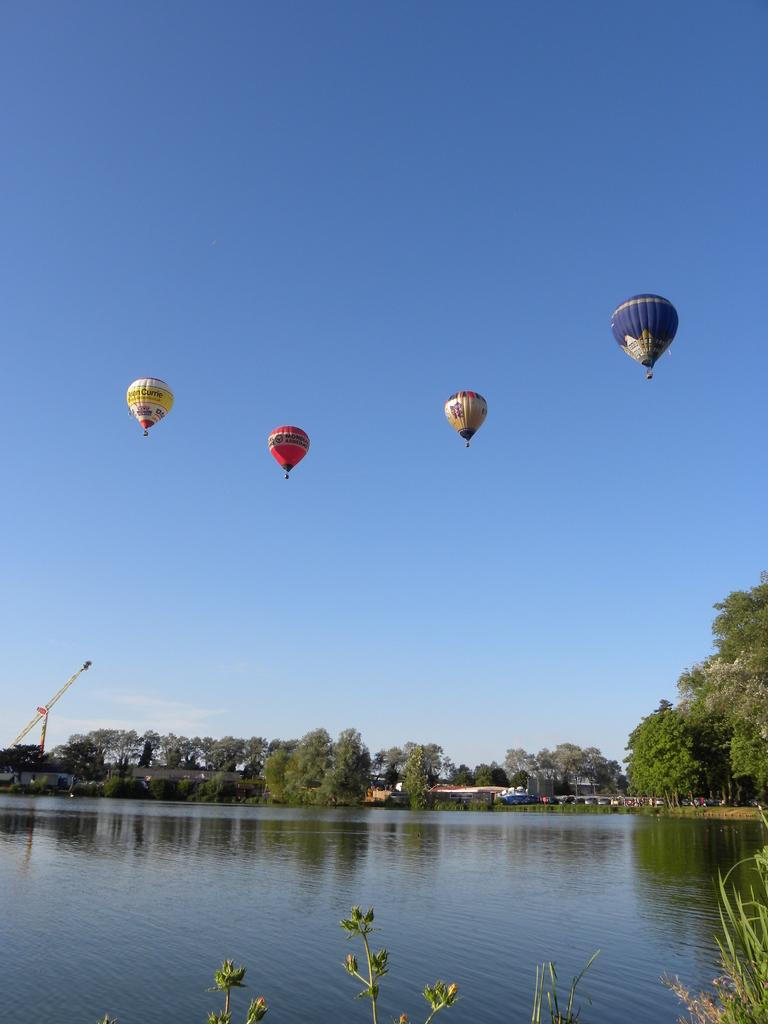What is in the air in the image? There are hot air balloons in the air in the image. What type of vegetation can be seen in the image? There are trees visible in the image. What natural element is visible in the image? There is water visible in the image. What type of structures can be seen in the image? There are houses in the image. What construction equipment is present in the image? There is a crane in the image. What is the color of the sky in the image? The sky is blue in the image. Where is the board used for playing games in the image? There is no board used for playing games present in the image. What type of magic is being performed in the image? There is no magic being performed in the image. 